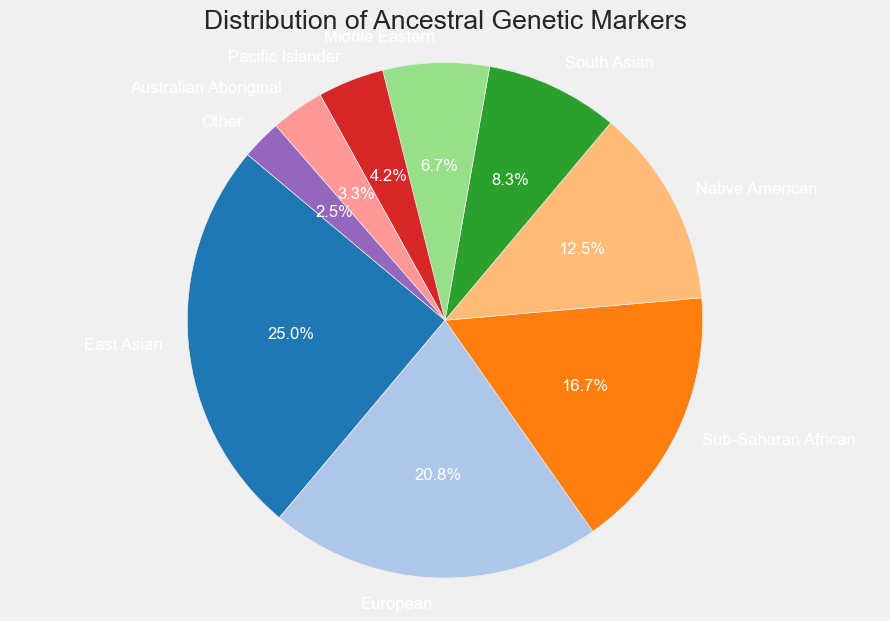Which ancestral marker has the largest representation in the population? From the pie chart, the largest wedge corresponds to the "East Asian" label.
Answer: East Asian What percentage of the population has European ancestry? From the pie chart, the wedge for "European" shows an autopct value of 25%.
Answer: 25% How many ancestral markers have a representation of less than 10%? From the pie chart, we need to count the wedges that display percentages less than 10%. These include "Middle Eastern", "Pacific Islander", "Australian Aboriginal", and "Other", totaling four markers.
Answer: 4 Which two ancestral markers have the smallest frequencies, and what are their combined percentages? The smallest wedges correspond to "Australian Aboriginal" and "Other" with frequencies of 4 and 3 respectively. Their combined percentage can be calculated by summing up their individual percentages shown as 4% + 3% = 7%.
Answer: Australian Aboriginal and Other, 7% Is the percentage of Native American genetic markers higher or lower than that of South Asian markers? The pie chart shows that Native American markers represent 15%, whereas South Asian markers represent 10%, so 15% is higher than 10%.
Answer: Higher What is the total percentage of Sub-Saharan African and Middle Eastern genetic markers combined? The pie chart indicates Sub-Saharan African markers are 20% and Middle Eastern markers are 8%. Adding these together gives 20% + 8% = 28%.
Answer: 28% How much larger is the representation of East Asian markers compared to Pacific Islander markers? The pie chart shows East Asian markers at 30% and Pacific Islander markers at 5%. The difference is 30% - 5% = 25%.
Answer: 25% Rank the ancestral markers listed in descending order based on their frequency representation. By examining the pie chart, we can order them as follows: East Asian (30%), European (25%), Sub-Saharan African (20%), Native American (15%), South Asian (10%), Middle Eastern (8%), Pacific Islander (5%), Australian Aboriginal (4%), Other (3%).
Answer: East Asian, European, Sub-Saharan African, Native American, South Asian, Middle Eastern, Pacific Islander, Australian Aboriginal, Other Which ancestral marker has the closest frequency to that of Native American markers? Native American markers are shown at 15%. The closest frequency to this is Sub-Saharan African markers, shown at 20%.
Answer: Sub-Saharan African What is the cumulative percentage for the top three most frequent ancestral markers? The top three markers are East Asian (30%), European (25%), and Sub-Saharan African (20%). Adding these gives 30% + 25% + 20% = 75%.
Answer: 75% 